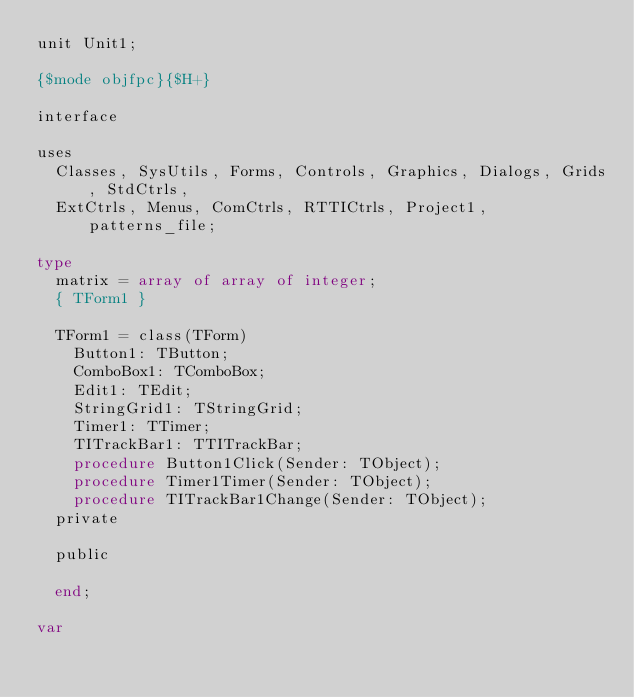<code> <loc_0><loc_0><loc_500><loc_500><_Pascal_>unit Unit1;

{$mode objfpc}{$H+}

interface

uses
  Classes, SysUtils, Forms, Controls, Graphics, Dialogs, Grids, StdCtrls,
  ExtCtrls, Menus, ComCtrls, RTTICtrls, Project1, patterns_file;

type
  matrix = array of array of integer;
  { TForm1 }

  TForm1 = class(TForm)
    Button1: TButton;
    ComboBox1: TComboBox;
    Edit1: TEdit;
    StringGrid1: TStringGrid;
    Timer1: TTimer;
    TITrackBar1: TTITrackBar;
    procedure Button1Click(Sender: TObject);
    procedure Timer1Timer(Sender: TObject);
    procedure TITrackBar1Change(Sender: TObject);
  private

  public

  end;

var</code> 